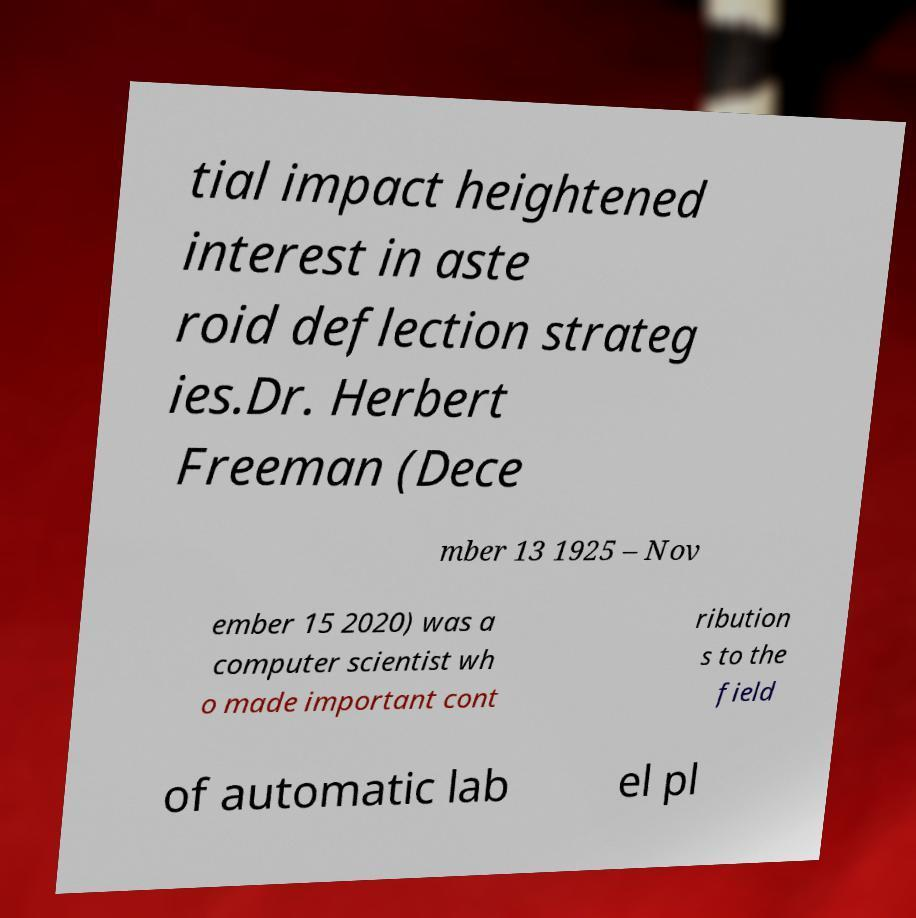Could you extract and type out the text from this image? tial impact heightened interest in aste roid deflection strateg ies.Dr. Herbert Freeman (Dece mber 13 1925 – Nov ember 15 2020) was a computer scientist wh o made important cont ribution s to the field of automatic lab el pl 